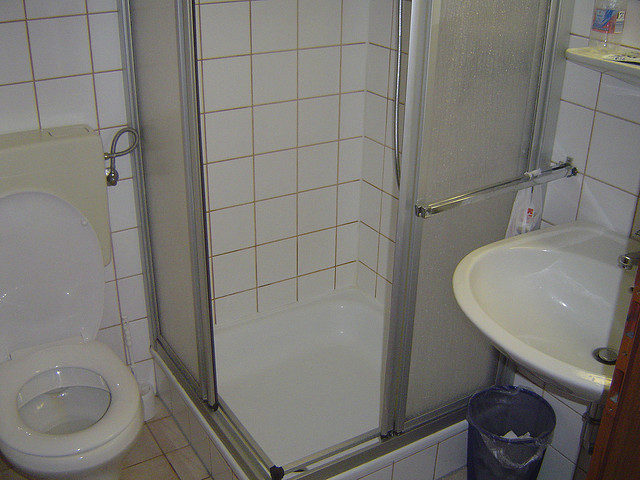Write a detailed description of the given image. The image depicts a small, typical bathroom setting. On the left side of the image, there is a white toilet positioned close to the wall with a tiled background. Adjacent to the toilet, in the center of the image, is a shower cubicle with a sliding glass door, which occupies a considerable portion of the bathroom. The tiles around the shower are white with a slight brownish grid pattern. To the right, there is a white sink with a smooth, rounded basin, fixed with a silver faucet. Above the sink, there's a shelf close to the edge of the image with a bottle placed very near the edge. A small wastebasket is situated under the sink. The overall aesthetic of the bathroom is clean and functional. 